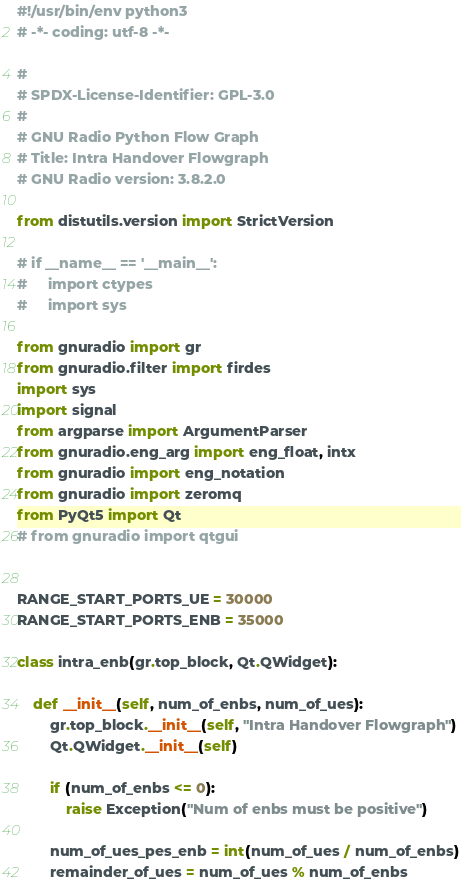<code> <loc_0><loc_0><loc_500><loc_500><_Python_>#!/usr/bin/env python3
# -*- coding: utf-8 -*-

#
# SPDX-License-Identifier: GPL-3.0
#
# GNU Radio Python Flow Graph
# Title: Intra Handover Flowgraph
# GNU Radio version: 3.8.2.0

from distutils.version import StrictVersion

# if __name__ == '__main__':
#     import ctypes
#     import sys

from gnuradio import gr
from gnuradio.filter import firdes
import sys
import signal
from argparse import ArgumentParser
from gnuradio.eng_arg import eng_float, intx
from gnuradio import eng_notation
from gnuradio import zeromq
from PyQt5 import Qt
# from gnuradio import qtgui


RANGE_START_PORTS_UE = 30000
RANGE_START_PORTS_ENB = 35000

class intra_enb(gr.top_block, Qt.QWidget):

    def __init__(self, num_of_enbs, num_of_ues):
        gr.top_block.__init__(self, "Intra Handover Flowgraph")
        Qt.QWidget.__init__(self)

        if (num_of_enbs <= 0):
            raise Exception("Num of enbs must be positive")

        num_of_ues_pes_enb = int(num_of_ues / num_of_enbs)
        remainder_of_ues = num_of_ues % num_of_enbs
</code> 